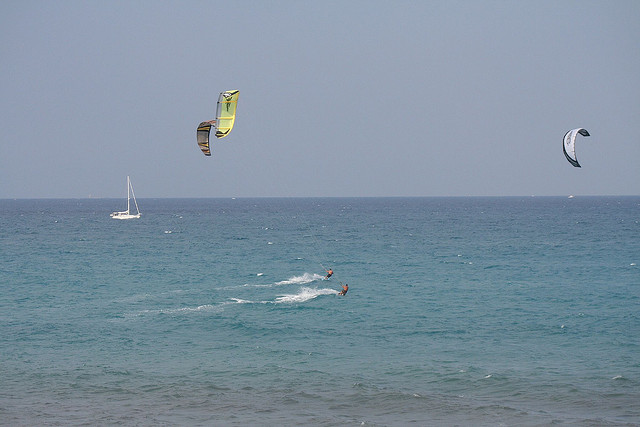How many people can you see participating in the parasailing activity? I can see two people participating in the kite surfing activity, both gliding over the water with parasails. 